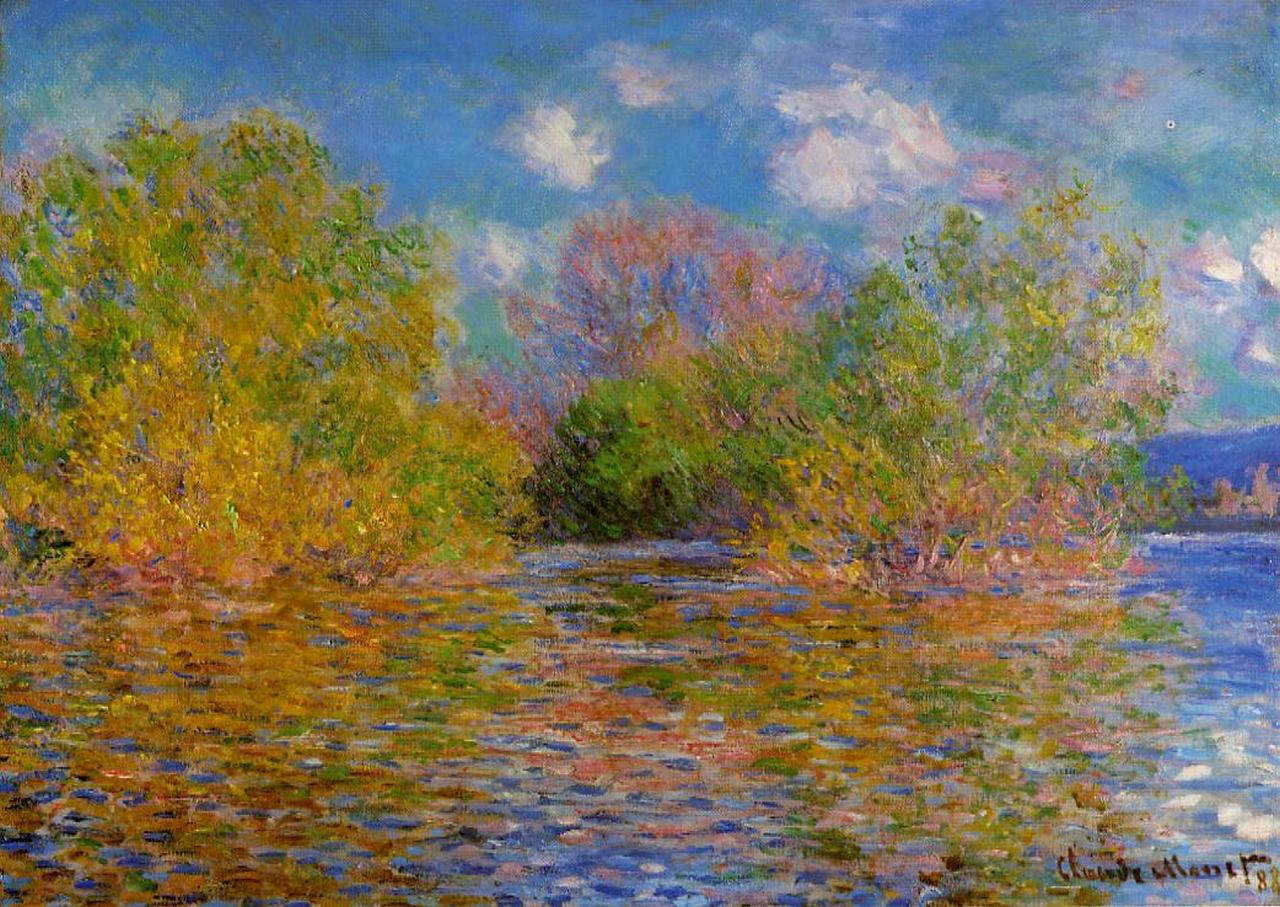What time of year do you think this scene depicts, and why? The scene likely depicts late summer or early fall. The foliage includes a mix of green leaves and those transitioning to yellow and reddish hues, indicating the change of seasons. The soft light and clear skies add to the suggestion of late summer warmth before the cooler weather sets in fully. How do you think the artist felt while painting this scene? Given the peaceful and harmonious nature of the scene, it is reasonable to infer that Monet felt a deep sense of tranquility and connection with nature while painting this. His choice of soothing colors and gentle brushstrokes seem to convey a serene and contemplative mood. If you could step into this painting, what sounds do you imagine you would hear? Stepping into this painting, one might hear the gentle rustling of leaves in the breeze, the soft lapping of the Seine’s waters against the riverbanks, the distant calls of birds, and perhaps the faint hum of bees visiting the foliage. It's a soundscape of calm and nature's subtle symphony. 